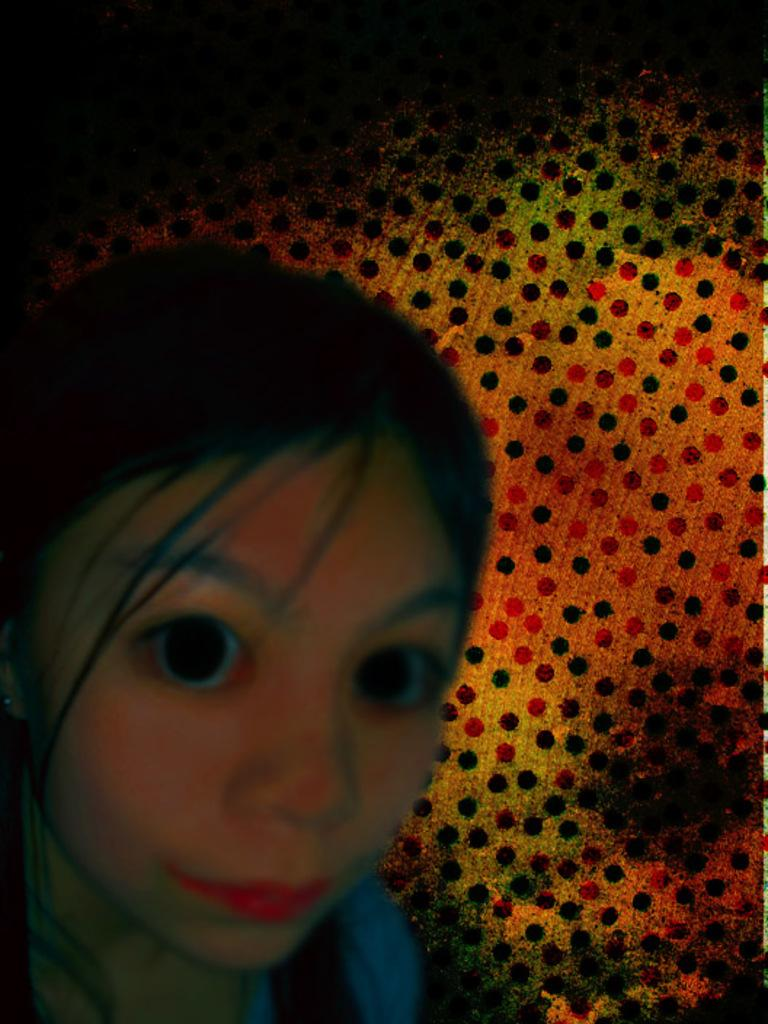Who is the main subject in the image? There is a girl in the image. Where is the girl located in the image? The girl is on the left side of the image. What can be seen in the background of the image? There is an object in the background of the image. Where is the object located in the image? The object is on the right side of the image. What type of soap is the girl using in the image? There is no soap present in the image. What kind of building can be seen in the background of the image? There is no building visible in the image; only an object is present in the background. 